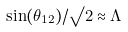<formula> <loc_0><loc_0><loc_500><loc_500>\sin ( \theta _ { 1 2 } ) / \surd 2 \approx \Lambda</formula> 